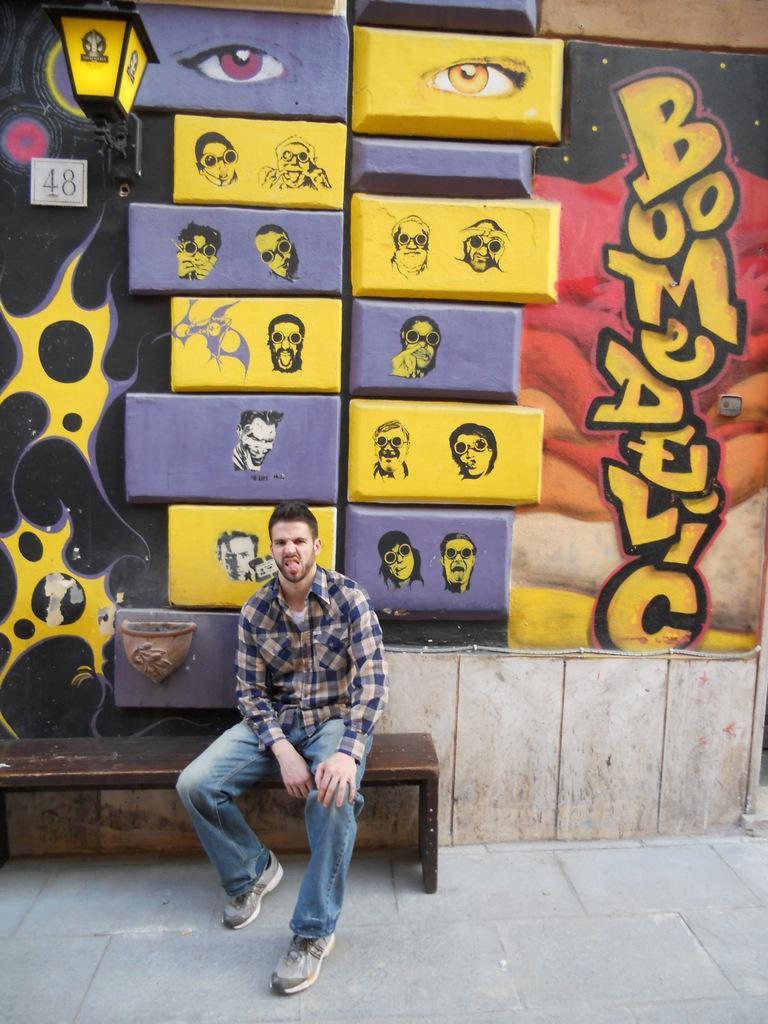Describe this image in one or two sentences. In this image there is a man sitting on the bench. In the background there is a wall and on the wall there is a painting and there is some text written and there are numbers written on the wall. 